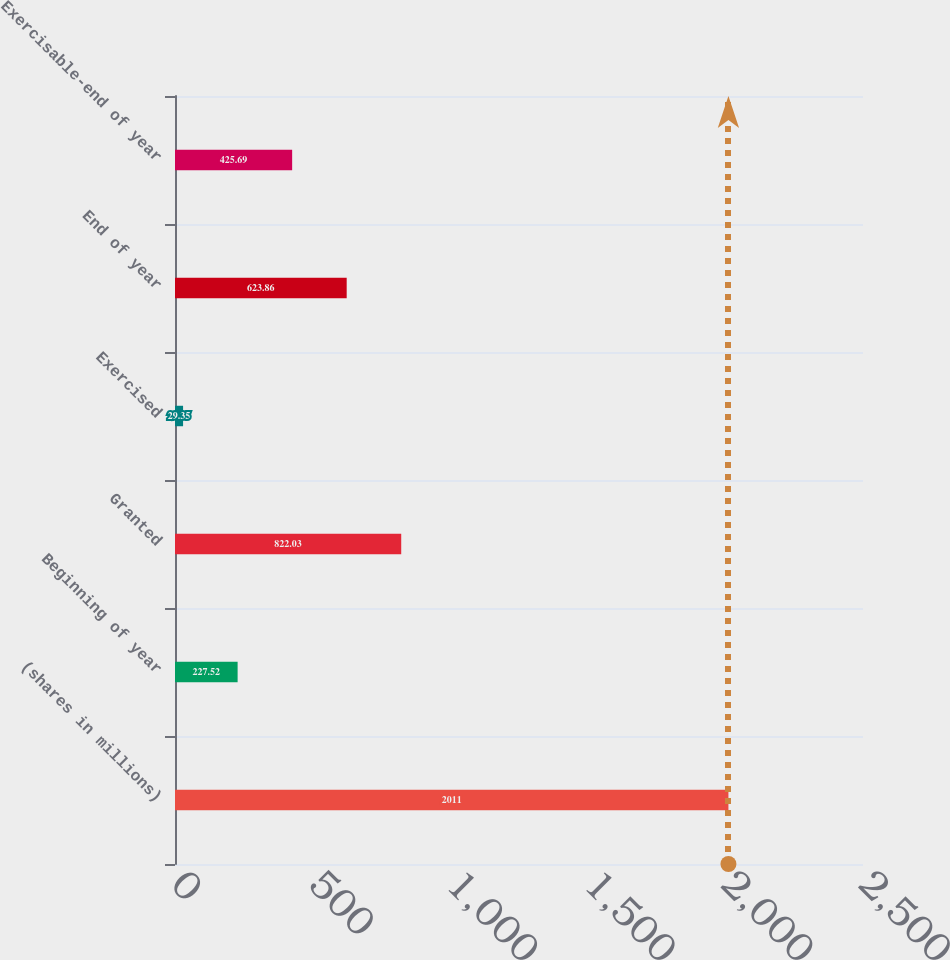Convert chart to OTSL. <chart><loc_0><loc_0><loc_500><loc_500><bar_chart><fcel>(shares in millions)<fcel>Beginning of year<fcel>Granted<fcel>Exercised<fcel>End of year<fcel>Exercisable-end of year<nl><fcel>2011<fcel>227.52<fcel>822.03<fcel>29.35<fcel>623.86<fcel>425.69<nl></chart> 